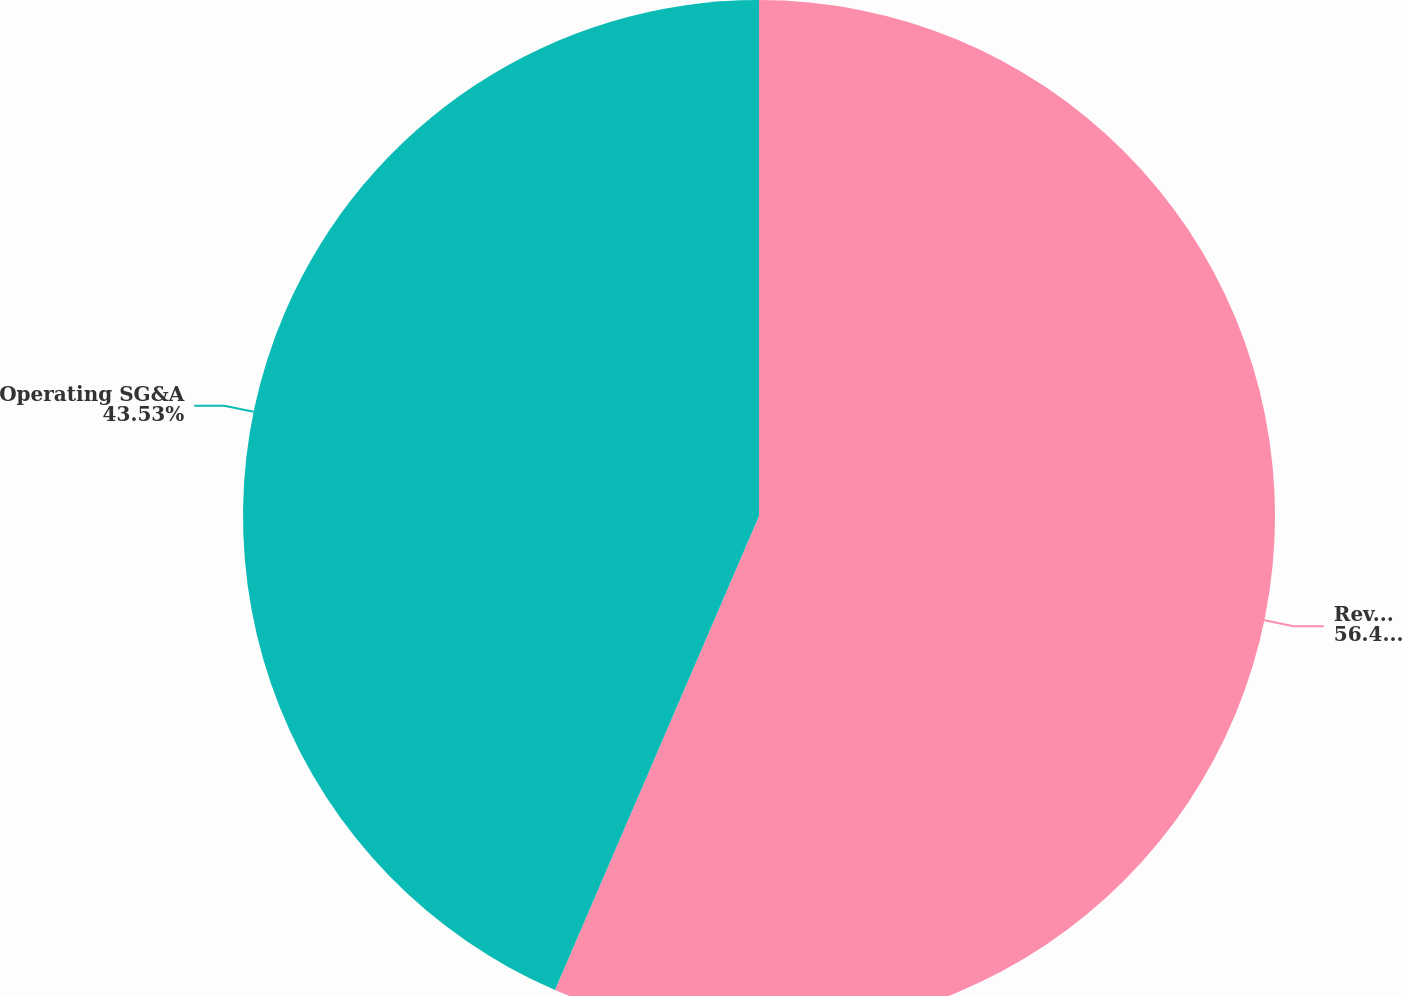<chart> <loc_0><loc_0><loc_500><loc_500><pie_chart><fcel>Revenue<fcel>Operating SG&A<nl><fcel>56.47%<fcel>43.53%<nl></chart> 